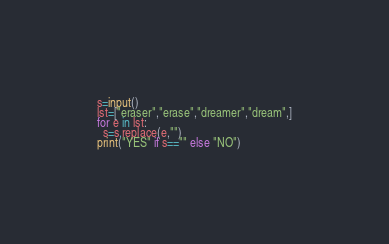Convert code to text. <code><loc_0><loc_0><loc_500><loc_500><_Python_>s=input()
lst=["eraser","erase","dreamer","dream",]
for e in lst: 
  s=s.replace(e,"")
print("YES" if s=="" else "NO")</code> 